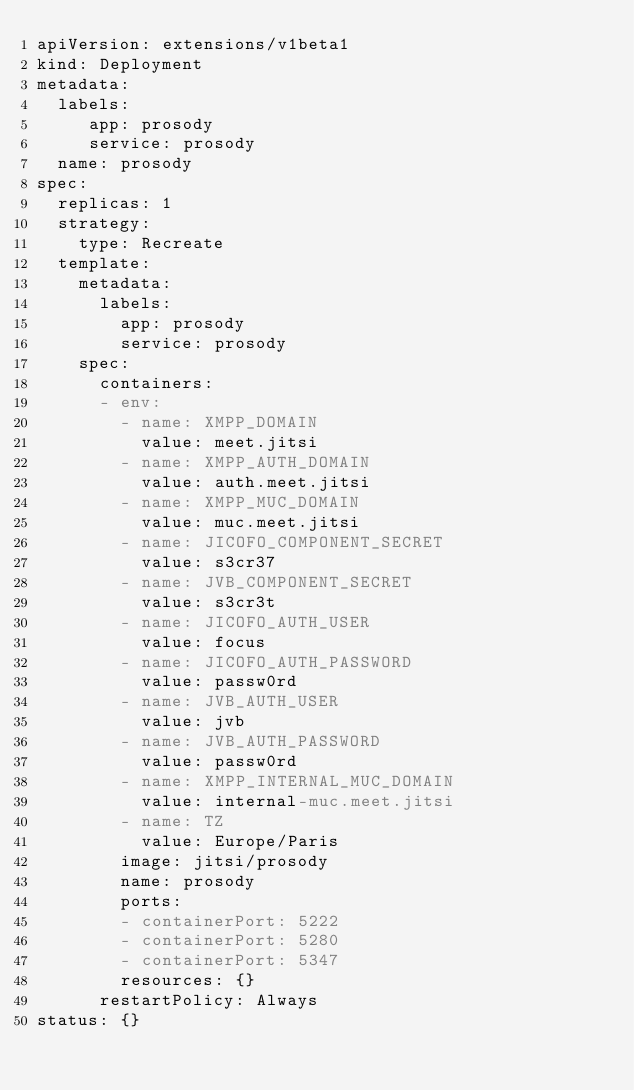Convert code to text. <code><loc_0><loc_0><loc_500><loc_500><_YAML_>apiVersion: extensions/v1beta1
kind: Deployment
metadata:
  labels:
     app: prosody
     service: prosody
  name: prosody
spec:
  replicas: 1
  strategy:
    type: Recreate
  template:
    metadata:
      labels:
        app: prosody 
        service: prosody
    spec:
      containers:
      - env:
        - name: XMPP_DOMAIN
          value: meet.jitsi
        - name: XMPP_AUTH_DOMAIN
          value: auth.meet.jitsi
        - name: XMPP_MUC_DOMAIN
          value: muc.meet.jitsi
        - name: JICOFO_COMPONENT_SECRET
          value: s3cr37
        - name: JVB_COMPONENT_SECRET
          value: s3cr3t
        - name: JICOFO_AUTH_USER
          value: focus
        - name: JICOFO_AUTH_PASSWORD
          value: passw0rd
        - name: JVB_AUTH_USER
          value: jvb
        - name: JVB_AUTH_PASSWORD
          value: passw0rd
        - name: XMPP_INTERNAL_MUC_DOMAIN
          value: internal-muc.meet.jitsi
        - name: TZ
          value: Europe/Paris
        image: jitsi/prosody
        name: prosody
        ports:
        - containerPort: 5222
        - containerPort: 5280
        - containerPort: 5347
        resources: {}
      restartPolicy: Always
status: {}
</code> 